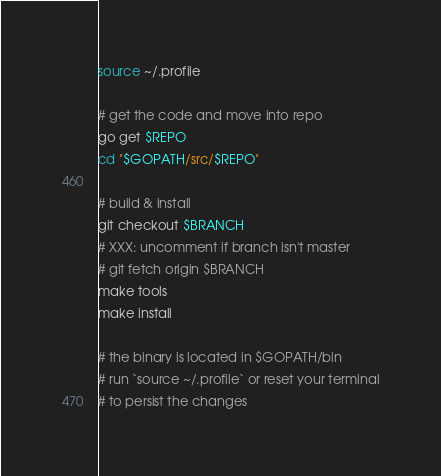Convert code to text. <code><loc_0><loc_0><loc_500><loc_500><_Bash_>source ~/.profile

# get the code and move into repo
go get $REPO
cd "$GOPATH/src/$REPO"

# build & install
git checkout $BRANCH
# XXX: uncomment if branch isn't master
# git fetch origin $BRANCH
make tools
make install

# the binary is located in $GOPATH/bin
# run `source ~/.profile` or reset your terminal
# to persist the changes
</code> 